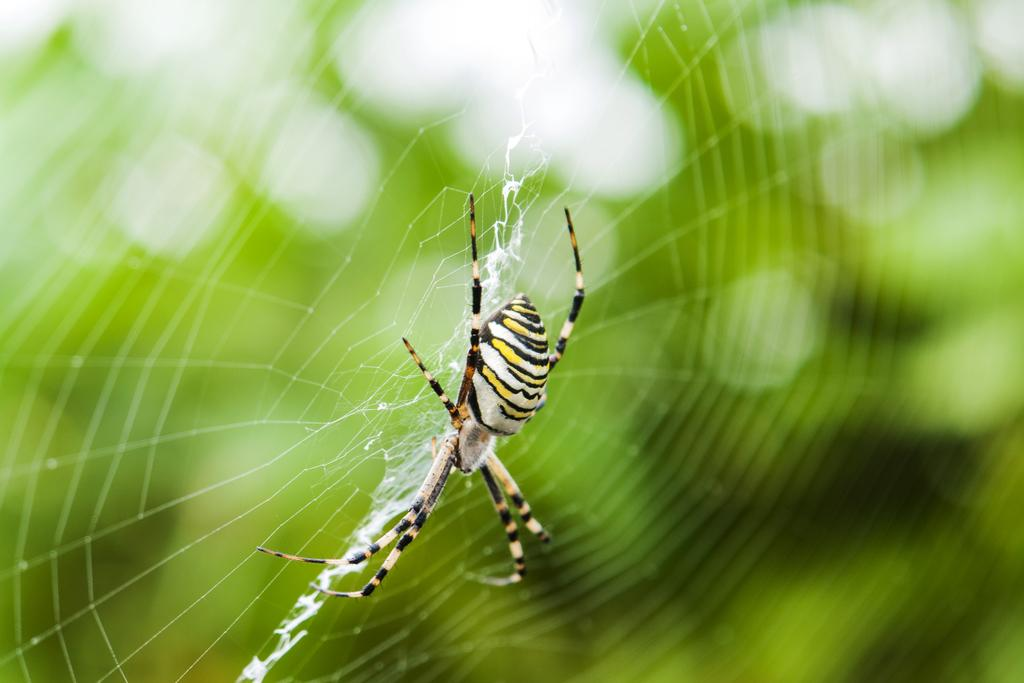What is the main subject of the image? There is a spider in the image. What is associated with the spider in the image? There is a spider web in the image. Can you describe the background of the image? The background of the image is blurred. What type of shoe is hanging from the spider web in the image? There is no shoe present in the image; it only features a spider and a spider web. How many tickets can be seen in the image? There are no tickets present in the image. 